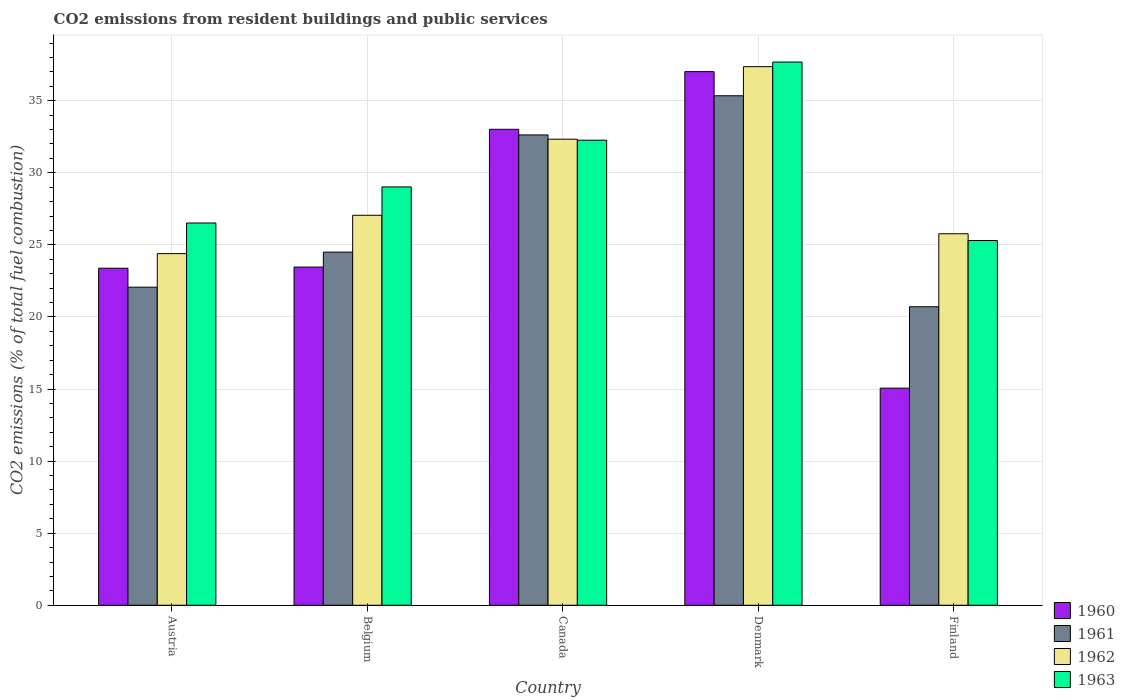How many different coloured bars are there?
Offer a terse response. 4. How many groups of bars are there?
Make the answer very short. 5. How many bars are there on the 1st tick from the right?
Give a very brief answer. 4. What is the total CO2 emitted in 1963 in Belgium?
Your response must be concise. 29.02. Across all countries, what is the maximum total CO2 emitted in 1963?
Give a very brief answer. 37.68. Across all countries, what is the minimum total CO2 emitted in 1962?
Keep it short and to the point. 24.39. In which country was the total CO2 emitted in 1960 minimum?
Your answer should be very brief. Finland. What is the total total CO2 emitted in 1961 in the graph?
Make the answer very short. 135.24. What is the difference between the total CO2 emitted in 1963 in Austria and that in Denmark?
Your answer should be compact. -11.17. What is the difference between the total CO2 emitted in 1961 in Belgium and the total CO2 emitted in 1963 in Finland?
Give a very brief answer. -0.8. What is the average total CO2 emitted in 1960 per country?
Ensure brevity in your answer.  26.39. What is the difference between the total CO2 emitted of/in 1963 and total CO2 emitted of/in 1961 in Denmark?
Your answer should be very brief. 2.34. What is the ratio of the total CO2 emitted in 1962 in Belgium to that in Denmark?
Your response must be concise. 0.72. Is the total CO2 emitted in 1963 in Austria less than that in Canada?
Give a very brief answer. Yes. What is the difference between the highest and the second highest total CO2 emitted in 1960?
Your answer should be compact. -4. What is the difference between the highest and the lowest total CO2 emitted in 1960?
Your response must be concise. 21.96. How many countries are there in the graph?
Your answer should be very brief. 5. What is the difference between two consecutive major ticks on the Y-axis?
Make the answer very short. 5. Does the graph contain any zero values?
Provide a succinct answer. No. Does the graph contain grids?
Ensure brevity in your answer.  Yes. Where does the legend appear in the graph?
Your response must be concise. Bottom right. How many legend labels are there?
Ensure brevity in your answer.  4. How are the legend labels stacked?
Your response must be concise. Vertical. What is the title of the graph?
Give a very brief answer. CO2 emissions from resident buildings and public services. Does "1960" appear as one of the legend labels in the graph?
Give a very brief answer. Yes. What is the label or title of the X-axis?
Keep it short and to the point. Country. What is the label or title of the Y-axis?
Keep it short and to the point. CO2 emissions (% of total fuel combustion). What is the CO2 emissions (% of total fuel combustion) in 1960 in Austria?
Provide a succinct answer. 23.38. What is the CO2 emissions (% of total fuel combustion) of 1961 in Austria?
Your response must be concise. 22.06. What is the CO2 emissions (% of total fuel combustion) of 1962 in Austria?
Give a very brief answer. 24.39. What is the CO2 emissions (% of total fuel combustion) in 1963 in Austria?
Keep it short and to the point. 26.52. What is the CO2 emissions (% of total fuel combustion) of 1960 in Belgium?
Your answer should be compact. 23.46. What is the CO2 emissions (% of total fuel combustion) in 1961 in Belgium?
Your response must be concise. 24.5. What is the CO2 emissions (% of total fuel combustion) in 1962 in Belgium?
Ensure brevity in your answer.  27.05. What is the CO2 emissions (% of total fuel combustion) in 1963 in Belgium?
Ensure brevity in your answer.  29.02. What is the CO2 emissions (% of total fuel combustion) of 1960 in Canada?
Your answer should be very brief. 33.01. What is the CO2 emissions (% of total fuel combustion) in 1961 in Canada?
Give a very brief answer. 32.63. What is the CO2 emissions (% of total fuel combustion) in 1962 in Canada?
Offer a very short reply. 32.33. What is the CO2 emissions (% of total fuel combustion) of 1963 in Canada?
Give a very brief answer. 32.26. What is the CO2 emissions (% of total fuel combustion) in 1960 in Denmark?
Your answer should be compact. 37.02. What is the CO2 emissions (% of total fuel combustion) in 1961 in Denmark?
Make the answer very short. 35.34. What is the CO2 emissions (% of total fuel combustion) in 1962 in Denmark?
Keep it short and to the point. 37.36. What is the CO2 emissions (% of total fuel combustion) in 1963 in Denmark?
Provide a short and direct response. 37.68. What is the CO2 emissions (% of total fuel combustion) of 1960 in Finland?
Give a very brief answer. 15.06. What is the CO2 emissions (% of total fuel combustion) of 1961 in Finland?
Ensure brevity in your answer.  20.71. What is the CO2 emissions (% of total fuel combustion) of 1962 in Finland?
Your response must be concise. 25.77. What is the CO2 emissions (% of total fuel combustion) in 1963 in Finland?
Offer a very short reply. 25.3. Across all countries, what is the maximum CO2 emissions (% of total fuel combustion) in 1960?
Keep it short and to the point. 37.02. Across all countries, what is the maximum CO2 emissions (% of total fuel combustion) in 1961?
Ensure brevity in your answer.  35.34. Across all countries, what is the maximum CO2 emissions (% of total fuel combustion) of 1962?
Your response must be concise. 37.36. Across all countries, what is the maximum CO2 emissions (% of total fuel combustion) of 1963?
Offer a very short reply. 37.68. Across all countries, what is the minimum CO2 emissions (% of total fuel combustion) in 1960?
Give a very brief answer. 15.06. Across all countries, what is the minimum CO2 emissions (% of total fuel combustion) in 1961?
Provide a short and direct response. 20.71. Across all countries, what is the minimum CO2 emissions (% of total fuel combustion) in 1962?
Provide a succinct answer. 24.39. Across all countries, what is the minimum CO2 emissions (% of total fuel combustion) of 1963?
Your response must be concise. 25.3. What is the total CO2 emissions (% of total fuel combustion) of 1960 in the graph?
Provide a short and direct response. 131.93. What is the total CO2 emissions (% of total fuel combustion) of 1961 in the graph?
Keep it short and to the point. 135.24. What is the total CO2 emissions (% of total fuel combustion) of 1962 in the graph?
Keep it short and to the point. 146.9. What is the total CO2 emissions (% of total fuel combustion) in 1963 in the graph?
Give a very brief answer. 150.78. What is the difference between the CO2 emissions (% of total fuel combustion) in 1960 in Austria and that in Belgium?
Offer a very short reply. -0.08. What is the difference between the CO2 emissions (% of total fuel combustion) in 1961 in Austria and that in Belgium?
Keep it short and to the point. -2.43. What is the difference between the CO2 emissions (% of total fuel combustion) in 1962 in Austria and that in Belgium?
Your answer should be compact. -2.66. What is the difference between the CO2 emissions (% of total fuel combustion) in 1963 in Austria and that in Belgium?
Provide a short and direct response. -2.5. What is the difference between the CO2 emissions (% of total fuel combustion) of 1960 in Austria and that in Canada?
Ensure brevity in your answer.  -9.64. What is the difference between the CO2 emissions (% of total fuel combustion) in 1961 in Austria and that in Canada?
Your answer should be very brief. -10.56. What is the difference between the CO2 emissions (% of total fuel combustion) of 1962 in Austria and that in Canada?
Provide a succinct answer. -7.94. What is the difference between the CO2 emissions (% of total fuel combustion) of 1963 in Austria and that in Canada?
Provide a short and direct response. -5.74. What is the difference between the CO2 emissions (% of total fuel combustion) of 1960 in Austria and that in Denmark?
Your response must be concise. -13.64. What is the difference between the CO2 emissions (% of total fuel combustion) in 1961 in Austria and that in Denmark?
Offer a terse response. -13.28. What is the difference between the CO2 emissions (% of total fuel combustion) of 1962 in Austria and that in Denmark?
Provide a succinct answer. -12.97. What is the difference between the CO2 emissions (% of total fuel combustion) in 1963 in Austria and that in Denmark?
Give a very brief answer. -11.17. What is the difference between the CO2 emissions (% of total fuel combustion) of 1960 in Austria and that in Finland?
Provide a succinct answer. 8.32. What is the difference between the CO2 emissions (% of total fuel combustion) in 1961 in Austria and that in Finland?
Keep it short and to the point. 1.36. What is the difference between the CO2 emissions (% of total fuel combustion) in 1962 in Austria and that in Finland?
Provide a short and direct response. -1.38. What is the difference between the CO2 emissions (% of total fuel combustion) of 1963 in Austria and that in Finland?
Provide a succinct answer. 1.22. What is the difference between the CO2 emissions (% of total fuel combustion) in 1960 in Belgium and that in Canada?
Your answer should be compact. -9.56. What is the difference between the CO2 emissions (% of total fuel combustion) of 1961 in Belgium and that in Canada?
Give a very brief answer. -8.13. What is the difference between the CO2 emissions (% of total fuel combustion) of 1962 in Belgium and that in Canada?
Offer a very short reply. -5.28. What is the difference between the CO2 emissions (% of total fuel combustion) in 1963 in Belgium and that in Canada?
Your answer should be compact. -3.24. What is the difference between the CO2 emissions (% of total fuel combustion) of 1960 in Belgium and that in Denmark?
Make the answer very short. -13.56. What is the difference between the CO2 emissions (% of total fuel combustion) in 1961 in Belgium and that in Denmark?
Your answer should be compact. -10.85. What is the difference between the CO2 emissions (% of total fuel combustion) of 1962 in Belgium and that in Denmark?
Give a very brief answer. -10.31. What is the difference between the CO2 emissions (% of total fuel combustion) of 1963 in Belgium and that in Denmark?
Your answer should be very brief. -8.66. What is the difference between the CO2 emissions (% of total fuel combustion) in 1960 in Belgium and that in Finland?
Offer a very short reply. 8.4. What is the difference between the CO2 emissions (% of total fuel combustion) in 1961 in Belgium and that in Finland?
Keep it short and to the point. 3.79. What is the difference between the CO2 emissions (% of total fuel combustion) in 1962 in Belgium and that in Finland?
Provide a short and direct response. 1.28. What is the difference between the CO2 emissions (% of total fuel combustion) of 1963 in Belgium and that in Finland?
Make the answer very short. 3.72. What is the difference between the CO2 emissions (% of total fuel combustion) of 1960 in Canada and that in Denmark?
Provide a short and direct response. -4. What is the difference between the CO2 emissions (% of total fuel combustion) in 1961 in Canada and that in Denmark?
Provide a short and direct response. -2.72. What is the difference between the CO2 emissions (% of total fuel combustion) in 1962 in Canada and that in Denmark?
Ensure brevity in your answer.  -5.03. What is the difference between the CO2 emissions (% of total fuel combustion) in 1963 in Canada and that in Denmark?
Your response must be concise. -5.42. What is the difference between the CO2 emissions (% of total fuel combustion) in 1960 in Canada and that in Finland?
Ensure brevity in your answer.  17.96. What is the difference between the CO2 emissions (% of total fuel combustion) in 1961 in Canada and that in Finland?
Provide a succinct answer. 11.92. What is the difference between the CO2 emissions (% of total fuel combustion) of 1962 in Canada and that in Finland?
Ensure brevity in your answer.  6.56. What is the difference between the CO2 emissions (% of total fuel combustion) of 1963 in Canada and that in Finland?
Keep it short and to the point. 6.96. What is the difference between the CO2 emissions (% of total fuel combustion) of 1960 in Denmark and that in Finland?
Provide a succinct answer. 21.96. What is the difference between the CO2 emissions (% of total fuel combustion) in 1961 in Denmark and that in Finland?
Give a very brief answer. 14.64. What is the difference between the CO2 emissions (% of total fuel combustion) of 1962 in Denmark and that in Finland?
Your answer should be very brief. 11.59. What is the difference between the CO2 emissions (% of total fuel combustion) in 1963 in Denmark and that in Finland?
Make the answer very short. 12.38. What is the difference between the CO2 emissions (% of total fuel combustion) of 1960 in Austria and the CO2 emissions (% of total fuel combustion) of 1961 in Belgium?
Provide a short and direct response. -1.12. What is the difference between the CO2 emissions (% of total fuel combustion) of 1960 in Austria and the CO2 emissions (% of total fuel combustion) of 1962 in Belgium?
Your answer should be very brief. -3.67. What is the difference between the CO2 emissions (% of total fuel combustion) of 1960 in Austria and the CO2 emissions (% of total fuel combustion) of 1963 in Belgium?
Offer a terse response. -5.64. What is the difference between the CO2 emissions (% of total fuel combustion) of 1961 in Austria and the CO2 emissions (% of total fuel combustion) of 1962 in Belgium?
Make the answer very short. -4.99. What is the difference between the CO2 emissions (% of total fuel combustion) of 1961 in Austria and the CO2 emissions (% of total fuel combustion) of 1963 in Belgium?
Provide a succinct answer. -6.95. What is the difference between the CO2 emissions (% of total fuel combustion) in 1962 in Austria and the CO2 emissions (% of total fuel combustion) in 1963 in Belgium?
Make the answer very short. -4.63. What is the difference between the CO2 emissions (% of total fuel combustion) of 1960 in Austria and the CO2 emissions (% of total fuel combustion) of 1961 in Canada?
Make the answer very short. -9.25. What is the difference between the CO2 emissions (% of total fuel combustion) in 1960 in Austria and the CO2 emissions (% of total fuel combustion) in 1962 in Canada?
Make the answer very short. -8.95. What is the difference between the CO2 emissions (% of total fuel combustion) of 1960 in Austria and the CO2 emissions (% of total fuel combustion) of 1963 in Canada?
Your answer should be very brief. -8.88. What is the difference between the CO2 emissions (% of total fuel combustion) in 1961 in Austria and the CO2 emissions (% of total fuel combustion) in 1962 in Canada?
Ensure brevity in your answer.  -10.26. What is the difference between the CO2 emissions (% of total fuel combustion) of 1961 in Austria and the CO2 emissions (% of total fuel combustion) of 1963 in Canada?
Ensure brevity in your answer.  -10.2. What is the difference between the CO2 emissions (% of total fuel combustion) in 1962 in Austria and the CO2 emissions (% of total fuel combustion) in 1963 in Canada?
Keep it short and to the point. -7.87. What is the difference between the CO2 emissions (% of total fuel combustion) in 1960 in Austria and the CO2 emissions (% of total fuel combustion) in 1961 in Denmark?
Provide a short and direct response. -11.96. What is the difference between the CO2 emissions (% of total fuel combustion) of 1960 in Austria and the CO2 emissions (% of total fuel combustion) of 1962 in Denmark?
Keep it short and to the point. -13.98. What is the difference between the CO2 emissions (% of total fuel combustion) of 1960 in Austria and the CO2 emissions (% of total fuel combustion) of 1963 in Denmark?
Offer a terse response. -14.3. What is the difference between the CO2 emissions (% of total fuel combustion) in 1961 in Austria and the CO2 emissions (% of total fuel combustion) in 1962 in Denmark?
Keep it short and to the point. -15.3. What is the difference between the CO2 emissions (% of total fuel combustion) in 1961 in Austria and the CO2 emissions (% of total fuel combustion) in 1963 in Denmark?
Make the answer very short. -15.62. What is the difference between the CO2 emissions (% of total fuel combustion) in 1962 in Austria and the CO2 emissions (% of total fuel combustion) in 1963 in Denmark?
Provide a succinct answer. -13.29. What is the difference between the CO2 emissions (% of total fuel combustion) of 1960 in Austria and the CO2 emissions (% of total fuel combustion) of 1961 in Finland?
Ensure brevity in your answer.  2.67. What is the difference between the CO2 emissions (% of total fuel combustion) in 1960 in Austria and the CO2 emissions (% of total fuel combustion) in 1962 in Finland?
Make the answer very short. -2.39. What is the difference between the CO2 emissions (% of total fuel combustion) of 1960 in Austria and the CO2 emissions (% of total fuel combustion) of 1963 in Finland?
Provide a succinct answer. -1.92. What is the difference between the CO2 emissions (% of total fuel combustion) of 1961 in Austria and the CO2 emissions (% of total fuel combustion) of 1962 in Finland?
Your answer should be very brief. -3.71. What is the difference between the CO2 emissions (% of total fuel combustion) of 1961 in Austria and the CO2 emissions (% of total fuel combustion) of 1963 in Finland?
Give a very brief answer. -3.24. What is the difference between the CO2 emissions (% of total fuel combustion) in 1962 in Austria and the CO2 emissions (% of total fuel combustion) in 1963 in Finland?
Your answer should be very brief. -0.91. What is the difference between the CO2 emissions (% of total fuel combustion) in 1960 in Belgium and the CO2 emissions (% of total fuel combustion) in 1961 in Canada?
Your answer should be very brief. -9.17. What is the difference between the CO2 emissions (% of total fuel combustion) in 1960 in Belgium and the CO2 emissions (% of total fuel combustion) in 1962 in Canada?
Provide a succinct answer. -8.87. What is the difference between the CO2 emissions (% of total fuel combustion) of 1960 in Belgium and the CO2 emissions (% of total fuel combustion) of 1963 in Canada?
Provide a short and direct response. -8.8. What is the difference between the CO2 emissions (% of total fuel combustion) in 1961 in Belgium and the CO2 emissions (% of total fuel combustion) in 1962 in Canada?
Provide a succinct answer. -7.83. What is the difference between the CO2 emissions (% of total fuel combustion) of 1961 in Belgium and the CO2 emissions (% of total fuel combustion) of 1963 in Canada?
Your response must be concise. -7.76. What is the difference between the CO2 emissions (% of total fuel combustion) of 1962 in Belgium and the CO2 emissions (% of total fuel combustion) of 1963 in Canada?
Your response must be concise. -5.21. What is the difference between the CO2 emissions (% of total fuel combustion) in 1960 in Belgium and the CO2 emissions (% of total fuel combustion) in 1961 in Denmark?
Keep it short and to the point. -11.88. What is the difference between the CO2 emissions (% of total fuel combustion) in 1960 in Belgium and the CO2 emissions (% of total fuel combustion) in 1962 in Denmark?
Make the answer very short. -13.9. What is the difference between the CO2 emissions (% of total fuel combustion) in 1960 in Belgium and the CO2 emissions (% of total fuel combustion) in 1963 in Denmark?
Ensure brevity in your answer.  -14.22. What is the difference between the CO2 emissions (% of total fuel combustion) in 1961 in Belgium and the CO2 emissions (% of total fuel combustion) in 1962 in Denmark?
Give a very brief answer. -12.86. What is the difference between the CO2 emissions (% of total fuel combustion) in 1961 in Belgium and the CO2 emissions (% of total fuel combustion) in 1963 in Denmark?
Offer a terse response. -13.18. What is the difference between the CO2 emissions (% of total fuel combustion) in 1962 in Belgium and the CO2 emissions (% of total fuel combustion) in 1963 in Denmark?
Keep it short and to the point. -10.63. What is the difference between the CO2 emissions (% of total fuel combustion) in 1960 in Belgium and the CO2 emissions (% of total fuel combustion) in 1961 in Finland?
Ensure brevity in your answer.  2.75. What is the difference between the CO2 emissions (% of total fuel combustion) in 1960 in Belgium and the CO2 emissions (% of total fuel combustion) in 1962 in Finland?
Give a very brief answer. -2.31. What is the difference between the CO2 emissions (% of total fuel combustion) of 1960 in Belgium and the CO2 emissions (% of total fuel combustion) of 1963 in Finland?
Keep it short and to the point. -1.84. What is the difference between the CO2 emissions (% of total fuel combustion) of 1961 in Belgium and the CO2 emissions (% of total fuel combustion) of 1962 in Finland?
Your response must be concise. -1.27. What is the difference between the CO2 emissions (% of total fuel combustion) in 1961 in Belgium and the CO2 emissions (% of total fuel combustion) in 1963 in Finland?
Your answer should be very brief. -0.8. What is the difference between the CO2 emissions (% of total fuel combustion) of 1962 in Belgium and the CO2 emissions (% of total fuel combustion) of 1963 in Finland?
Ensure brevity in your answer.  1.75. What is the difference between the CO2 emissions (% of total fuel combustion) in 1960 in Canada and the CO2 emissions (% of total fuel combustion) in 1961 in Denmark?
Provide a succinct answer. -2.33. What is the difference between the CO2 emissions (% of total fuel combustion) of 1960 in Canada and the CO2 emissions (% of total fuel combustion) of 1962 in Denmark?
Your answer should be compact. -4.35. What is the difference between the CO2 emissions (% of total fuel combustion) of 1960 in Canada and the CO2 emissions (% of total fuel combustion) of 1963 in Denmark?
Ensure brevity in your answer.  -4.67. What is the difference between the CO2 emissions (% of total fuel combustion) in 1961 in Canada and the CO2 emissions (% of total fuel combustion) in 1962 in Denmark?
Offer a terse response. -4.73. What is the difference between the CO2 emissions (% of total fuel combustion) of 1961 in Canada and the CO2 emissions (% of total fuel combustion) of 1963 in Denmark?
Give a very brief answer. -5.06. What is the difference between the CO2 emissions (% of total fuel combustion) of 1962 in Canada and the CO2 emissions (% of total fuel combustion) of 1963 in Denmark?
Your response must be concise. -5.35. What is the difference between the CO2 emissions (% of total fuel combustion) in 1960 in Canada and the CO2 emissions (% of total fuel combustion) in 1961 in Finland?
Keep it short and to the point. 12.31. What is the difference between the CO2 emissions (% of total fuel combustion) of 1960 in Canada and the CO2 emissions (% of total fuel combustion) of 1962 in Finland?
Give a very brief answer. 7.25. What is the difference between the CO2 emissions (% of total fuel combustion) in 1960 in Canada and the CO2 emissions (% of total fuel combustion) in 1963 in Finland?
Give a very brief answer. 7.71. What is the difference between the CO2 emissions (% of total fuel combustion) of 1961 in Canada and the CO2 emissions (% of total fuel combustion) of 1962 in Finland?
Provide a short and direct response. 6.86. What is the difference between the CO2 emissions (% of total fuel combustion) in 1961 in Canada and the CO2 emissions (% of total fuel combustion) in 1963 in Finland?
Make the answer very short. 7.33. What is the difference between the CO2 emissions (% of total fuel combustion) of 1962 in Canada and the CO2 emissions (% of total fuel combustion) of 1963 in Finland?
Make the answer very short. 7.03. What is the difference between the CO2 emissions (% of total fuel combustion) of 1960 in Denmark and the CO2 emissions (% of total fuel combustion) of 1961 in Finland?
Keep it short and to the point. 16.31. What is the difference between the CO2 emissions (% of total fuel combustion) in 1960 in Denmark and the CO2 emissions (% of total fuel combustion) in 1962 in Finland?
Your answer should be very brief. 11.25. What is the difference between the CO2 emissions (% of total fuel combustion) in 1960 in Denmark and the CO2 emissions (% of total fuel combustion) in 1963 in Finland?
Give a very brief answer. 11.71. What is the difference between the CO2 emissions (% of total fuel combustion) in 1961 in Denmark and the CO2 emissions (% of total fuel combustion) in 1962 in Finland?
Your response must be concise. 9.57. What is the difference between the CO2 emissions (% of total fuel combustion) in 1961 in Denmark and the CO2 emissions (% of total fuel combustion) in 1963 in Finland?
Give a very brief answer. 10.04. What is the difference between the CO2 emissions (% of total fuel combustion) of 1962 in Denmark and the CO2 emissions (% of total fuel combustion) of 1963 in Finland?
Give a very brief answer. 12.06. What is the average CO2 emissions (% of total fuel combustion) in 1960 per country?
Your response must be concise. 26.39. What is the average CO2 emissions (% of total fuel combustion) of 1961 per country?
Make the answer very short. 27.05. What is the average CO2 emissions (% of total fuel combustion) in 1962 per country?
Provide a succinct answer. 29.38. What is the average CO2 emissions (% of total fuel combustion) in 1963 per country?
Give a very brief answer. 30.16. What is the difference between the CO2 emissions (% of total fuel combustion) of 1960 and CO2 emissions (% of total fuel combustion) of 1961 in Austria?
Provide a succinct answer. 1.31. What is the difference between the CO2 emissions (% of total fuel combustion) of 1960 and CO2 emissions (% of total fuel combustion) of 1962 in Austria?
Provide a succinct answer. -1.01. What is the difference between the CO2 emissions (% of total fuel combustion) in 1960 and CO2 emissions (% of total fuel combustion) in 1963 in Austria?
Provide a succinct answer. -3.14. What is the difference between the CO2 emissions (% of total fuel combustion) in 1961 and CO2 emissions (% of total fuel combustion) in 1962 in Austria?
Offer a terse response. -2.33. What is the difference between the CO2 emissions (% of total fuel combustion) in 1961 and CO2 emissions (% of total fuel combustion) in 1963 in Austria?
Your response must be concise. -4.45. What is the difference between the CO2 emissions (% of total fuel combustion) of 1962 and CO2 emissions (% of total fuel combustion) of 1963 in Austria?
Provide a succinct answer. -2.12. What is the difference between the CO2 emissions (% of total fuel combustion) of 1960 and CO2 emissions (% of total fuel combustion) of 1961 in Belgium?
Offer a terse response. -1.04. What is the difference between the CO2 emissions (% of total fuel combustion) of 1960 and CO2 emissions (% of total fuel combustion) of 1962 in Belgium?
Offer a very short reply. -3.59. What is the difference between the CO2 emissions (% of total fuel combustion) of 1960 and CO2 emissions (% of total fuel combustion) of 1963 in Belgium?
Your answer should be compact. -5.56. What is the difference between the CO2 emissions (% of total fuel combustion) in 1961 and CO2 emissions (% of total fuel combustion) in 1962 in Belgium?
Provide a short and direct response. -2.55. What is the difference between the CO2 emissions (% of total fuel combustion) in 1961 and CO2 emissions (% of total fuel combustion) in 1963 in Belgium?
Offer a terse response. -4.52. What is the difference between the CO2 emissions (% of total fuel combustion) of 1962 and CO2 emissions (% of total fuel combustion) of 1963 in Belgium?
Ensure brevity in your answer.  -1.97. What is the difference between the CO2 emissions (% of total fuel combustion) of 1960 and CO2 emissions (% of total fuel combustion) of 1961 in Canada?
Offer a terse response. 0.39. What is the difference between the CO2 emissions (% of total fuel combustion) in 1960 and CO2 emissions (% of total fuel combustion) in 1962 in Canada?
Ensure brevity in your answer.  0.69. What is the difference between the CO2 emissions (% of total fuel combustion) of 1960 and CO2 emissions (% of total fuel combustion) of 1963 in Canada?
Your response must be concise. 0.75. What is the difference between the CO2 emissions (% of total fuel combustion) in 1961 and CO2 emissions (% of total fuel combustion) in 1962 in Canada?
Make the answer very short. 0.3. What is the difference between the CO2 emissions (% of total fuel combustion) in 1961 and CO2 emissions (% of total fuel combustion) in 1963 in Canada?
Your answer should be very brief. 0.37. What is the difference between the CO2 emissions (% of total fuel combustion) of 1962 and CO2 emissions (% of total fuel combustion) of 1963 in Canada?
Make the answer very short. 0.07. What is the difference between the CO2 emissions (% of total fuel combustion) in 1960 and CO2 emissions (% of total fuel combustion) in 1961 in Denmark?
Offer a terse response. 1.67. What is the difference between the CO2 emissions (% of total fuel combustion) in 1960 and CO2 emissions (% of total fuel combustion) in 1962 in Denmark?
Provide a short and direct response. -0.34. What is the difference between the CO2 emissions (% of total fuel combustion) of 1960 and CO2 emissions (% of total fuel combustion) of 1963 in Denmark?
Your answer should be very brief. -0.67. What is the difference between the CO2 emissions (% of total fuel combustion) in 1961 and CO2 emissions (% of total fuel combustion) in 1962 in Denmark?
Give a very brief answer. -2.02. What is the difference between the CO2 emissions (% of total fuel combustion) in 1961 and CO2 emissions (% of total fuel combustion) in 1963 in Denmark?
Make the answer very short. -2.34. What is the difference between the CO2 emissions (% of total fuel combustion) of 1962 and CO2 emissions (% of total fuel combustion) of 1963 in Denmark?
Provide a succinct answer. -0.32. What is the difference between the CO2 emissions (% of total fuel combustion) in 1960 and CO2 emissions (% of total fuel combustion) in 1961 in Finland?
Offer a very short reply. -5.65. What is the difference between the CO2 emissions (% of total fuel combustion) of 1960 and CO2 emissions (% of total fuel combustion) of 1962 in Finland?
Offer a terse response. -10.71. What is the difference between the CO2 emissions (% of total fuel combustion) in 1960 and CO2 emissions (% of total fuel combustion) in 1963 in Finland?
Ensure brevity in your answer.  -10.24. What is the difference between the CO2 emissions (% of total fuel combustion) in 1961 and CO2 emissions (% of total fuel combustion) in 1962 in Finland?
Provide a succinct answer. -5.06. What is the difference between the CO2 emissions (% of total fuel combustion) of 1961 and CO2 emissions (% of total fuel combustion) of 1963 in Finland?
Provide a short and direct response. -4.59. What is the difference between the CO2 emissions (% of total fuel combustion) in 1962 and CO2 emissions (% of total fuel combustion) in 1963 in Finland?
Provide a short and direct response. 0.47. What is the ratio of the CO2 emissions (% of total fuel combustion) of 1960 in Austria to that in Belgium?
Offer a terse response. 1. What is the ratio of the CO2 emissions (% of total fuel combustion) in 1961 in Austria to that in Belgium?
Your response must be concise. 0.9. What is the ratio of the CO2 emissions (% of total fuel combustion) of 1962 in Austria to that in Belgium?
Provide a short and direct response. 0.9. What is the ratio of the CO2 emissions (% of total fuel combustion) in 1963 in Austria to that in Belgium?
Give a very brief answer. 0.91. What is the ratio of the CO2 emissions (% of total fuel combustion) of 1960 in Austria to that in Canada?
Your answer should be very brief. 0.71. What is the ratio of the CO2 emissions (% of total fuel combustion) of 1961 in Austria to that in Canada?
Offer a very short reply. 0.68. What is the ratio of the CO2 emissions (% of total fuel combustion) in 1962 in Austria to that in Canada?
Keep it short and to the point. 0.75. What is the ratio of the CO2 emissions (% of total fuel combustion) in 1963 in Austria to that in Canada?
Ensure brevity in your answer.  0.82. What is the ratio of the CO2 emissions (% of total fuel combustion) in 1960 in Austria to that in Denmark?
Ensure brevity in your answer.  0.63. What is the ratio of the CO2 emissions (% of total fuel combustion) of 1961 in Austria to that in Denmark?
Your response must be concise. 0.62. What is the ratio of the CO2 emissions (% of total fuel combustion) in 1962 in Austria to that in Denmark?
Offer a very short reply. 0.65. What is the ratio of the CO2 emissions (% of total fuel combustion) in 1963 in Austria to that in Denmark?
Offer a terse response. 0.7. What is the ratio of the CO2 emissions (% of total fuel combustion) in 1960 in Austria to that in Finland?
Your response must be concise. 1.55. What is the ratio of the CO2 emissions (% of total fuel combustion) of 1961 in Austria to that in Finland?
Offer a terse response. 1.07. What is the ratio of the CO2 emissions (% of total fuel combustion) in 1962 in Austria to that in Finland?
Your response must be concise. 0.95. What is the ratio of the CO2 emissions (% of total fuel combustion) of 1963 in Austria to that in Finland?
Provide a short and direct response. 1.05. What is the ratio of the CO2 emissions (% of total fuel combustion) of 1960 in Belgium to that in Canada?
Ensure brevity in your answer.  0.71. What is the ratio of the CO2 emissions (% of total fuel combustion) in 1961 in Belgium to that in Canada?
Make the answer very short. 0.75. What is the ratio of the CO2 emissions (% of total fuel combustion) of 1962 in Belgium to that in Canada?
Offer a terse response. 0.84. What is the ratio of the CO2 emissions (% of total fuel combustion) of 1963 in Belgium to that in Canada?
Your response must be concise. 0.9. What is the ratio of the CO2 emissions (% of total fuel combustion) in 1960 in Belgium to that in Denmark?
Your answer should be compact. 0.63. What is the ratio of the CO2 emissions (% of total fuel combustion) of 1961 in Belgium to that in Denmark?
Ensure brevity in your answer.  0.69. What is the ratio of the CO2 emissions (% of total fuel combustion) in 1962 in Belgium to that in Denmark?
Your response must be concise. 0.72. What is the ratio of the CO2 emissions (% of total fuel combustion) in 1963 in Belgium to that in Denmark?
Provide a short and direct response. 0.77. What is the ratio of the CO2 emissions (% of total fuel combustion) in 1960 in Belgium to that in Finland?
Ensure brevity in your answer.  1.56. What is the ratio of the CO2 emissions (% of total fuel combustion) in 1961 in Belgium to that in Finland?
Your answer should be compact. 1.18. What is the ratio of the CO2 emissions (% of total fuel combustion) in 1962 in Belgium to that in Finland?
Your answer should be compact. 1.05. What is the ratio of the CO2 emissions (% of total fuel combustion) in 1963 in Belgium to that in Finland?
Provide a short and direct response. 1.15. What is the ratio of the CO2 emissions (% of total fuel combustion) in 1960 in Canada to that in Denmark?
Your answer should be very brief. 0.89. What is the ratio of the CO2 emissions (% of total fuel combustion) of 1962 in Canada to that in Denmark?
Your answer should be compact. 0.87. What is the ratio of the CO2 emissions (% of total fuel combustion) of 1963 in Canada to that in Denmark?
Your answer should be compact. 0.86. What is the ratio of the CO2 emissions (% of total fuel combustion) of 1960 in Canada to that in Finland?
Give a very brief answer. 2.19. What is the ratio of the CO2 emissions (% of total fuel combustion) of 1961 in Canada to that in Finland?
Give a very brief answer. 1.58. What is the ratio of the CO2 emissions (% of total fuel combustion) in 1962 in Canada to that in Finland?
Ensure brevity in your answer.  1.25. What is the ratio of the CO2 emissions (% of total fuel combustion) in 1963 in Canada to that in Finland?
Offer a very short reply. 1.28. What is the ratio of the CO2 emissions (% of total fuel combustion) in 1960 in Denmark to that in Finland?
Your answer should be compact. 2.46. What is the ratio of the CO2 emissions (% of total fuel combustion) of 1961 in Denmark to that in Finland?
Your response must be concise. 1.71. What is the ratio of the CO2 emissions (% of total fuel combustion) of 1962 in Denmark to that in Finland?
Offer a terse response. 1.45. What is the ratio of the CO2 emissions (% of total fuel combustion) in 1963 in Denmark to that in Finland?
Provide a succinct answer. 1.49. What is the difference between the highest and the second highest CO2 emissions (% of total fuel combustion) of 1960?
Your response must be concise. 4. What is the difference between the highest and the second highest CO2 emissions (% of total fuel combustion) of 1961?
Your response must be concise. 2.72. What is the difference between the highest and the second highest CO2 emissions (% of total fuel combustion) of 1962?
Provide a short and direct response. 5.03. What is the difference between the highest and the second highest CO2 emissions (% of total fuel combustion) of 1963?
Your answer should be compact. 5.42. What is the difference between the highest and the lowest CO2 emissions (% of total fuel combustion) of 1960?
Your response must be concise. 21.96. What is the difference between the highest and the lowest CO2 emissions (% of total fuel combustion) in 1961?
Offer a very short reply. 14.64. What is the difference between the highest and the lowest CO2 emissions (% of total fuel combustion) of 1962?
Give a very brief answer. 12.97. What is the difference between the highest and the lowest CO2 emissions (% of total fuel combustion) of 1963?
Provide a short and direct response. 12.38. 